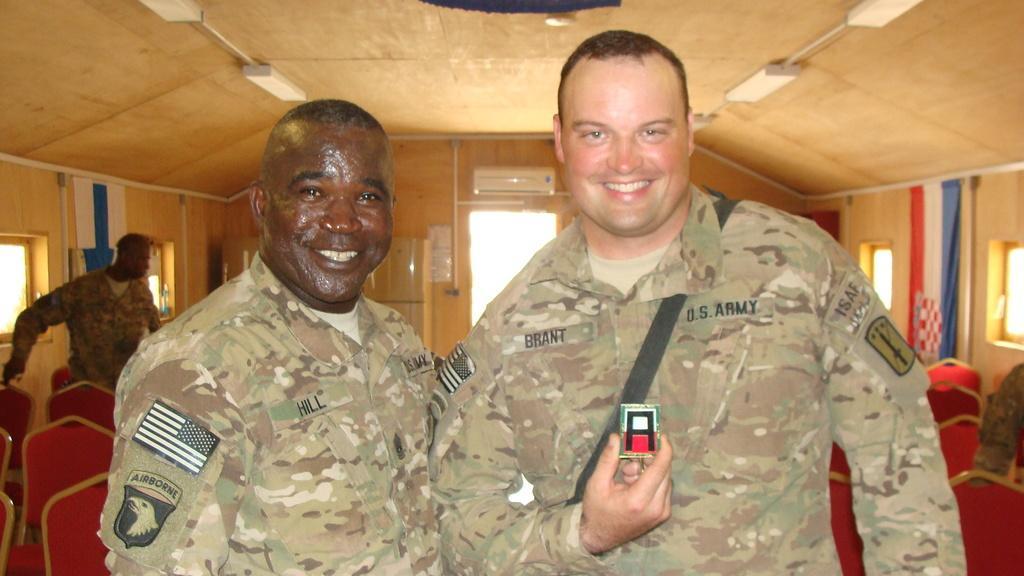Describe this image in one or two sentences. In this picture I can see there are two men standing and smiling, they are wearing army uniform and in the backdrop I can see there are few people people standing and there are empty chairs, doors and windows. 